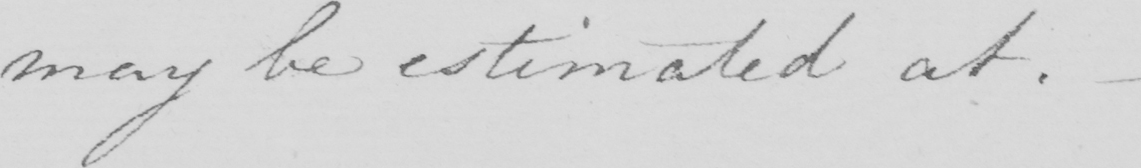What is written in this line of handwriting? may be estimated at . 